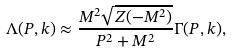<formula> <loc_0><loc_0><loc_500><loc_500>\Lambda ( P , k ) \approx \frac { M ^ { 2 } \sqrt { Z ( - M ^ { 2 } ) } } { P ^ { 2 } + M ^ { 2 } } \Gamma ( P , k ) ,</formula> 